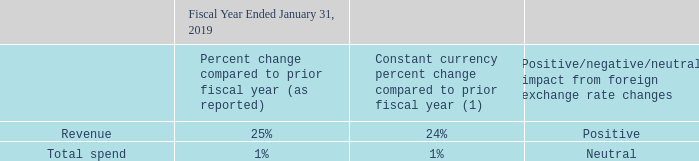Foreign Currency Analysis
We generate a significant amount of our revenue in the United States, Germany, Japan, the United Kingdom and Canada
The following table shows the impact of foreign exchange rate changes on our net revenue and total spend:
(1) Please refer to the Glossary of Terms for the definitions of our constant currency growth rates.
Changes in the value of the U.S. dollar may have a significant effect on net revenue, total spend, and income (loss) from operations in future periods. We use foreign currency contracts to reduce the exchange rate effect on a portion of the net revenue of certain anticipated transactions but do not attempt to completely mitigate the impact of fluctuations of such foreign currency against the U.S. dollar.
What is the impact of foreign exchange rate changes on net revenue? Positive. Which foreign exchange rate is likely to have the most impact on the company's operations? U.s. dollar. How does the company make use of foreign currency contracts? Reduce the exchange rate effect on a portion of the net revenue of certain anticipated transactions. How many countries make up most of the company's revenue? United States##Germany##Japan##the United Kingdom##Canada
Answer: 5. How much did the foreign exchange rate changes impact percent change in revenue?
Answer scale should be: percent. 25%-24% 
Answer: 1. How much did the foreign exchange rate changes impact percent change in total spend?
Answer scale should be: percent. 1%-1% 
Answer: 0. 